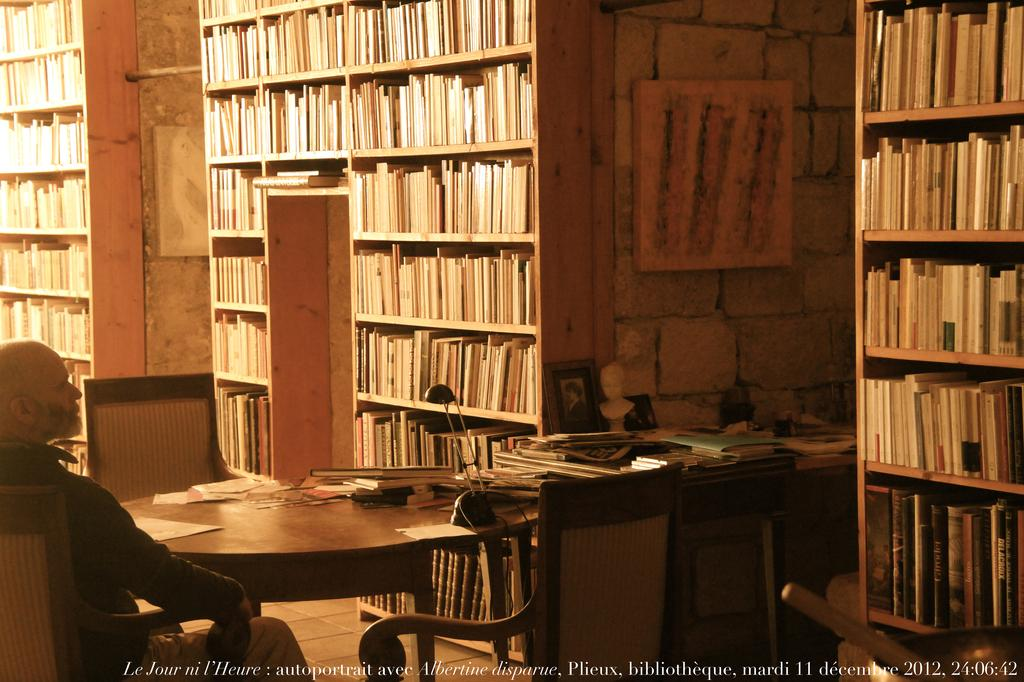<image>
Summarize the visual content of the image. a man sits in a library with words Jour Ni on the bottom 